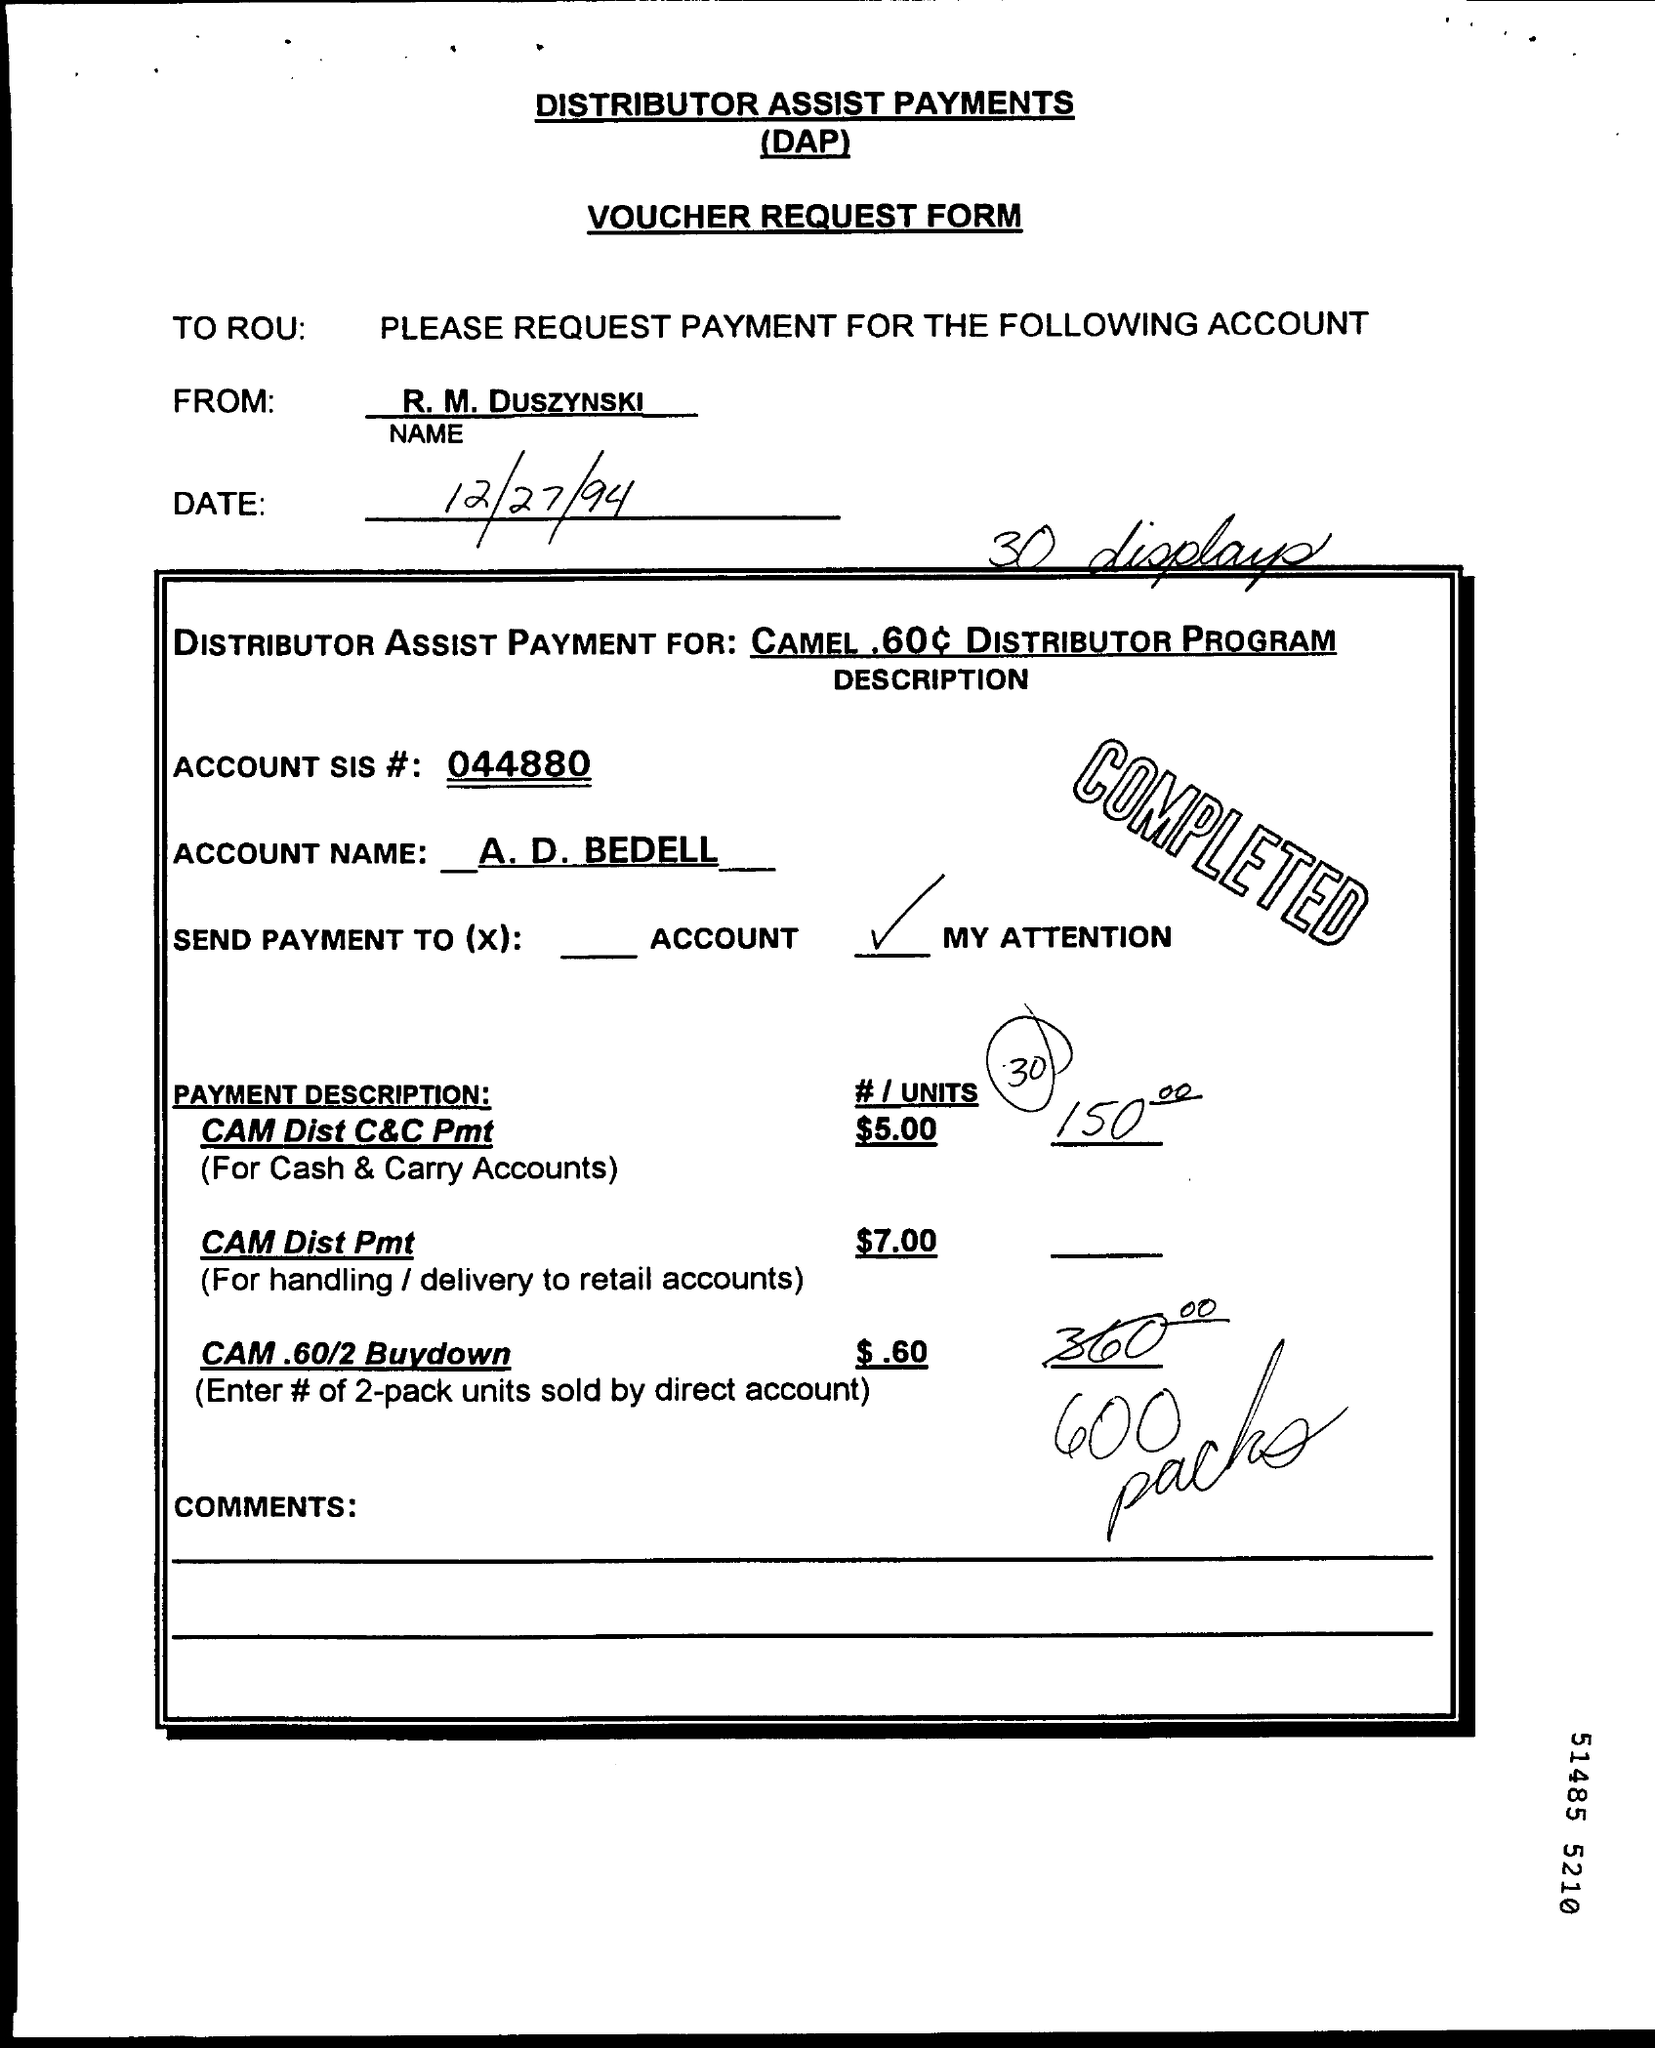What is the date printed?
Your response must be concise. 12/27/94. 